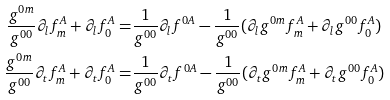<formula> <loc_0><loc_0><loc_500><loc_500>\frac { g ^ { 0 m } } { g ^ { 0 0 } } \partial _ { l } f _ { m } ^ { A } + \partial _ { l } f _ { 0 } ^ { A } = & \frac { 1 } { g ^ { 0 0 } } \partial _ { l } f ^ { 0 A } - \frac { 1 } { g ^ { 0 0 } } ( \partial _ { l } g ^ { 0 m } f _ { m } ^ { A } + \partial _ { l } g ^ { 0 0 } f _ { 0 } ^ { A } ) \\ \frac { g ^ { 0 m } } { g ^ { 0 0 } } \partial _ { t } f _ { m } ^ { A } + \partial _ { t } f _ { 0 } ^ { A } = & \frac { 1 } { g ^ { 0 0 } } \partial _ { t } f ^ { 0 A } - \frac { 1 } { g ^ { 0 0 } } ( \partial _ { t } g ^ { 0 m } f _ { m } ^ { A } + \partial _ { t } g ^ { 0 0 } f _ { 0 } ^ { A } )</formula> 